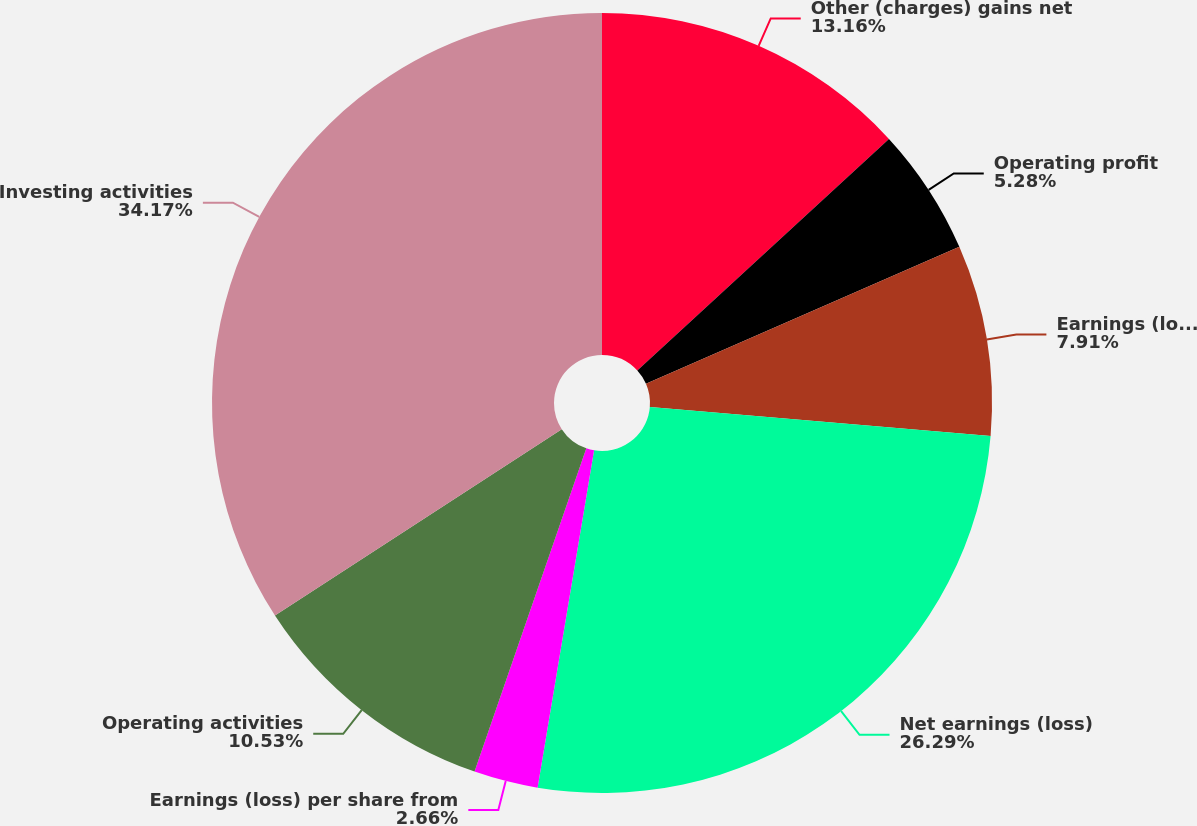<chart> <loc_0><loc_0><loc_500><loc_500><pie_chart><fcel>Other (charges) gains net<fcel>Operating profit<fcel>Earnings (loss) from<fcel>Net earnings (loss)<fcel>Earnings (loss) per share from<fcel>Operating activities<fcel>Investing activities<nl><fcel>13.16%<fcel>5.28%<fcel>7.91%<fcel>26.29%<fcel>2.66%<fcel>10.53%<fcel>34.17%<nl></chart> 